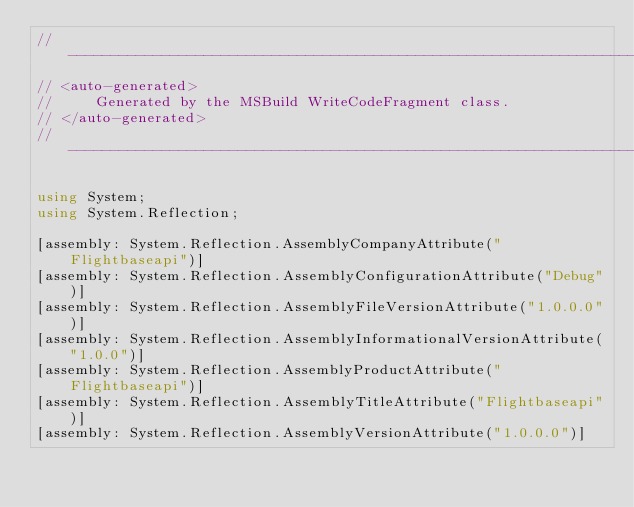Convert code to text. <code><loc_0><loc_0><loc_500><loc_500><_C#_>//------------------------------------------------------------------------------
// <auto-generated>
//     Generated by the MSBuild WriteCodeFragment class.
// </auto-generated>
//------------------------------------------------------------------------------

using System;
using System.Reflection;

[assembly: System.Reflection.AssemblyCompanyAttribute("Flightbaseapi")]
[assembly: System.Reflection.AssemblyConfigurationAttribute("Debug")]
[assembly: System.Reflection.AssemblyFileVersionAttribute("1.0.0.0")]
[assembly: System.Reflection.AssemblyInformationalVersionAttribute("1.0.0")]
[assembly: System.Reflection.AssemblyProductAttribute("Flightbaseapi")]
[assembly: System.Reflection.AssemblyTitleAttribute("Flightbaseapi")]
[assembly: System.Reflection.AssemblyVersionAttribute("1.0.0.0")]
</code> 